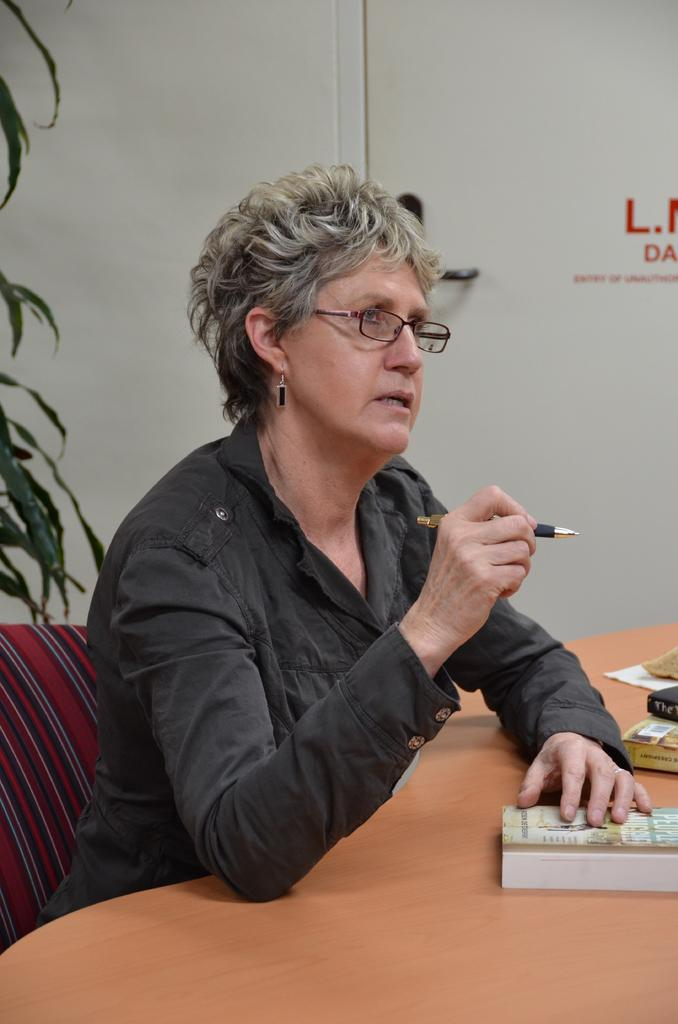What is the woman in the image doing? The woman is sitting in a chair. Where is the chair located in relation to the table? The chair is in front of a table. What items can be seen on the table? There are books on the table. Can you tell me how deep the lake is on the side of the woman in the image? There is no lake present in the image; it features a woman sitting in a chair in front of a table. 